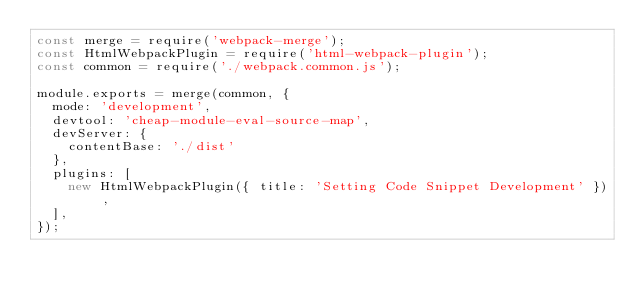Convert code to text. <code><loc_0><loc_0><loc_500><loc_500><_JavaScript_>const merge = require('webpack-merge');
const HtmlWebpackPlugin = require('html-webpack-plugin');
const common = require('./webpack.common.js');

module.exports = merge(common, {
  mode: 'development',
  devtool: 'cheap-module-eval-source-map',
  devServer: {
    contentBase: './dist'
  },
  plugins: [
    new HtmlWebpackPlugin({ title: 'Setting Code Snippet Development' }),
  ],
});</code> 